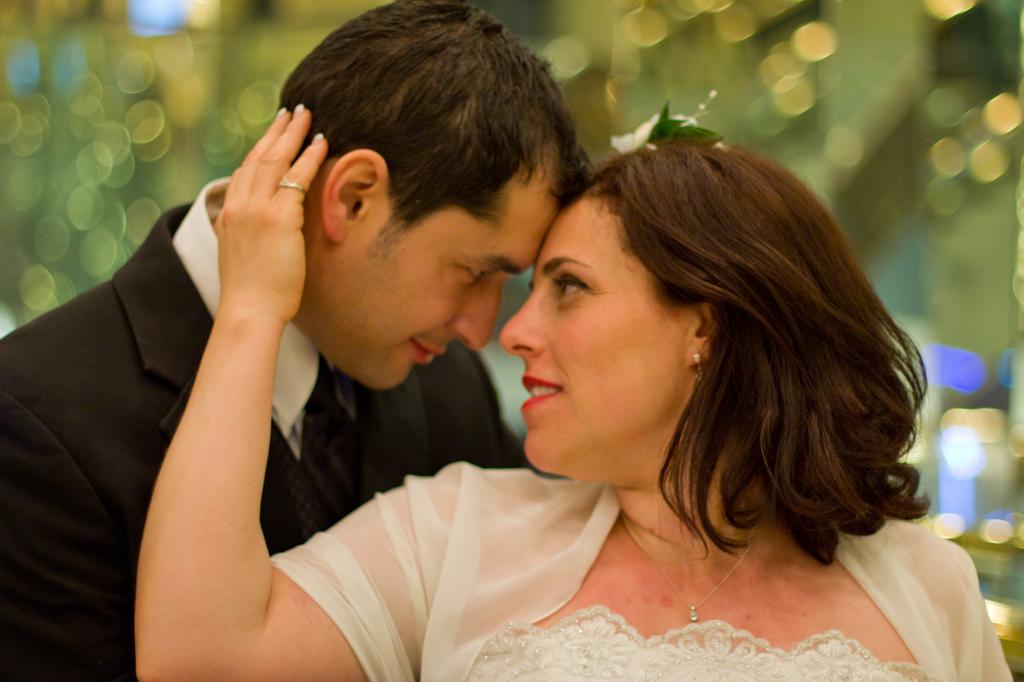Who are the people in the image? There is a man and a woman in the image. What are the man and woman doing in the image? The man and woman are looking at each other. Can you describe the background of the image? The background of the image is blurred. What type of substance is being used to slow down the car in the image? There is no car or substance present in the image; it features a man and a woman looking at each other with a blurred background. 